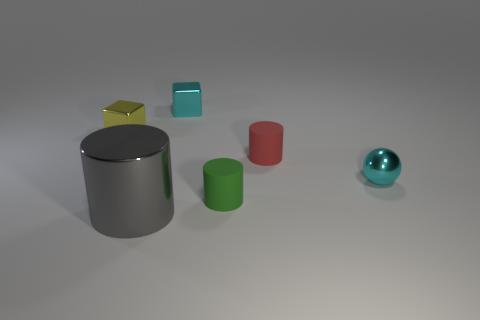Are there any other things that are the same size as the gray shiny cylinder?
Ensure brevity in your answer.  No. The metallic ball that is the same size as the yellow metallic object is what color?
Your response must be concise. Cyan. What is the material of the tiny cyan object to the right of the shiny block on the right side of the thing that is left of the gray metallic cylinder?
Keep it short and to the point. Metal. Does the small shiny ball have the same color as the small shiny thing behind the small yellow shiny thing?
Make the answer very short. Yes. How many objects are red rubber things right of the tiny green thing or objects right of the big shiny object?
Your answer should be compact. 4. There is a rubber thing in front of the cyan metallic object in front of the yellow thing; what shape is it?
Provide a short and direct response. Cylinder. Are there any tiny objects made of the same material as the small red cylinder?
Your answer should be very brief. Yes. The large metal object that is the same shape as the tiny green rubber thing is what color?
Offer a terse response. Gray. Is the number of small red cylinders that are in front of the gray thing less than the number of matte cylinders in front of the tiny red cylinder?
Offer a very short reply. Yes. What number of other objects are there of the same shape as the green rubber thing?
Provide a succinct answer. 2. 